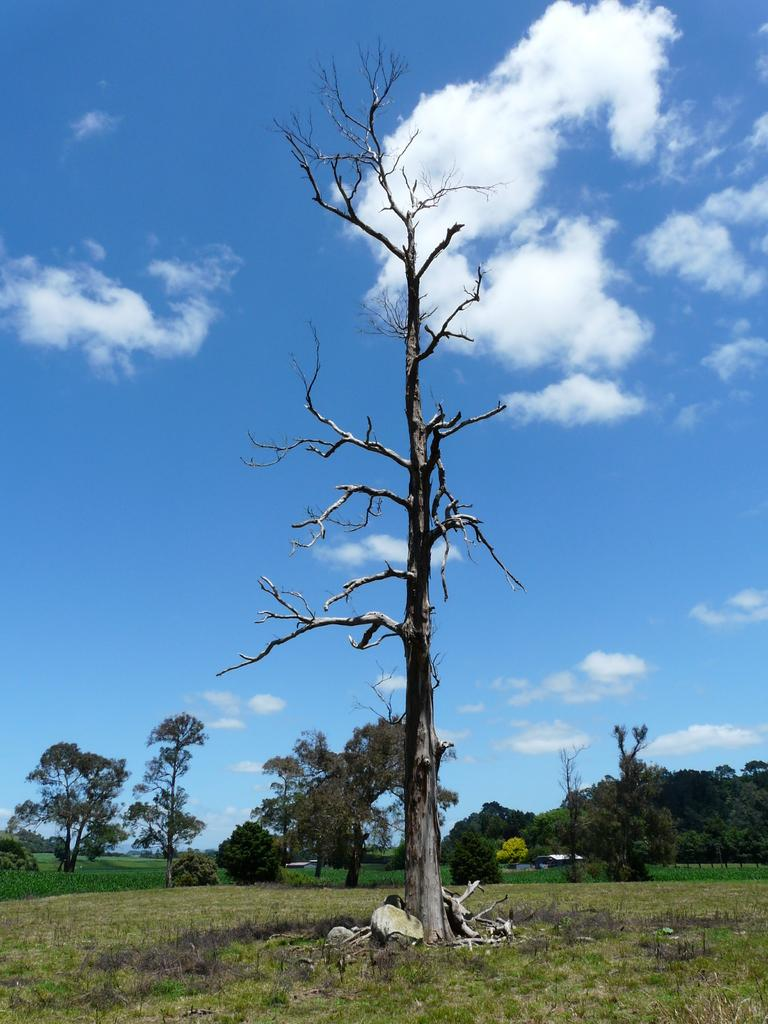What is the main subject of the image? There is a dry tree on the grassy land. What can be seen in the background of the image? Trees and the sky are visible in the background of the image. What is the condition of the sky in the image? The sky is visible in the background of the image, and there are little clouds present. Can you tell me how many frogs are sitting on the moon in the image? There is no moon or frogs present in the image; it features a dry tree on grassy land with trees and clouds in the background. 